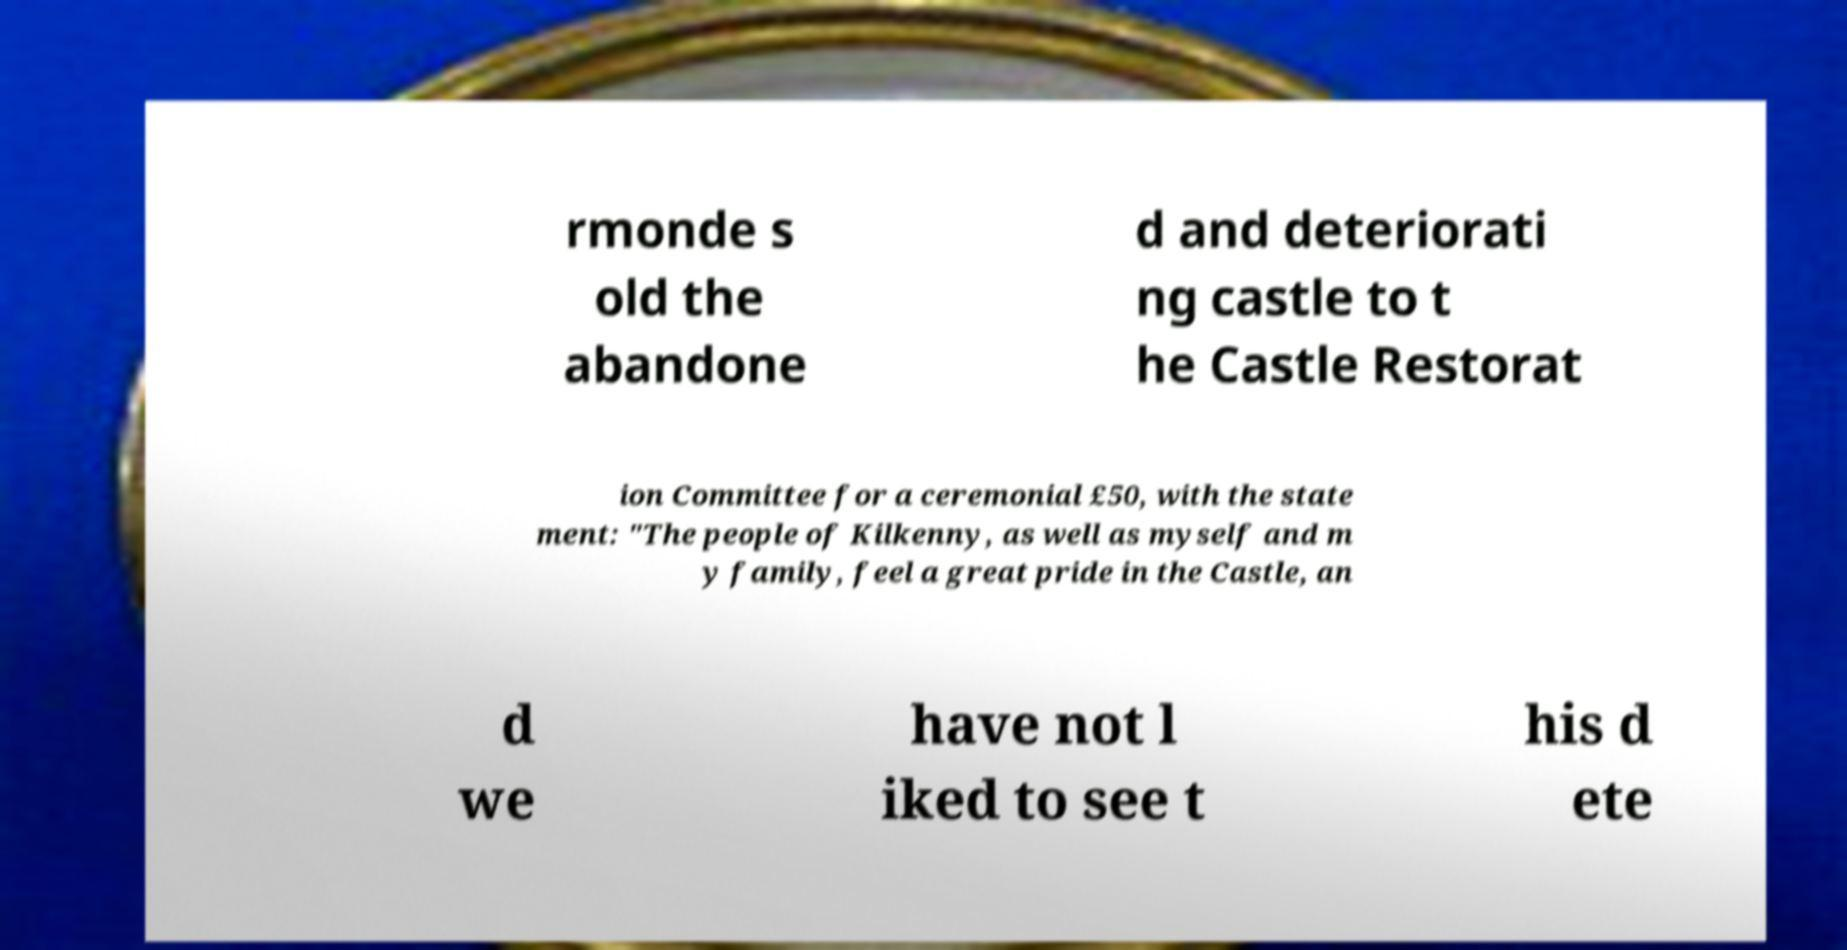Could you extract and type out the text from this image? rmonde s old the abandone d and deteriorati ng castle to t he Castle Restorat ion Committee for a ceremonial £50, with the state ment: "The people of Kilkenny, as well as myself and m y family, feel a great pride in the Castle, an d we have not l iked to see t his d ete 